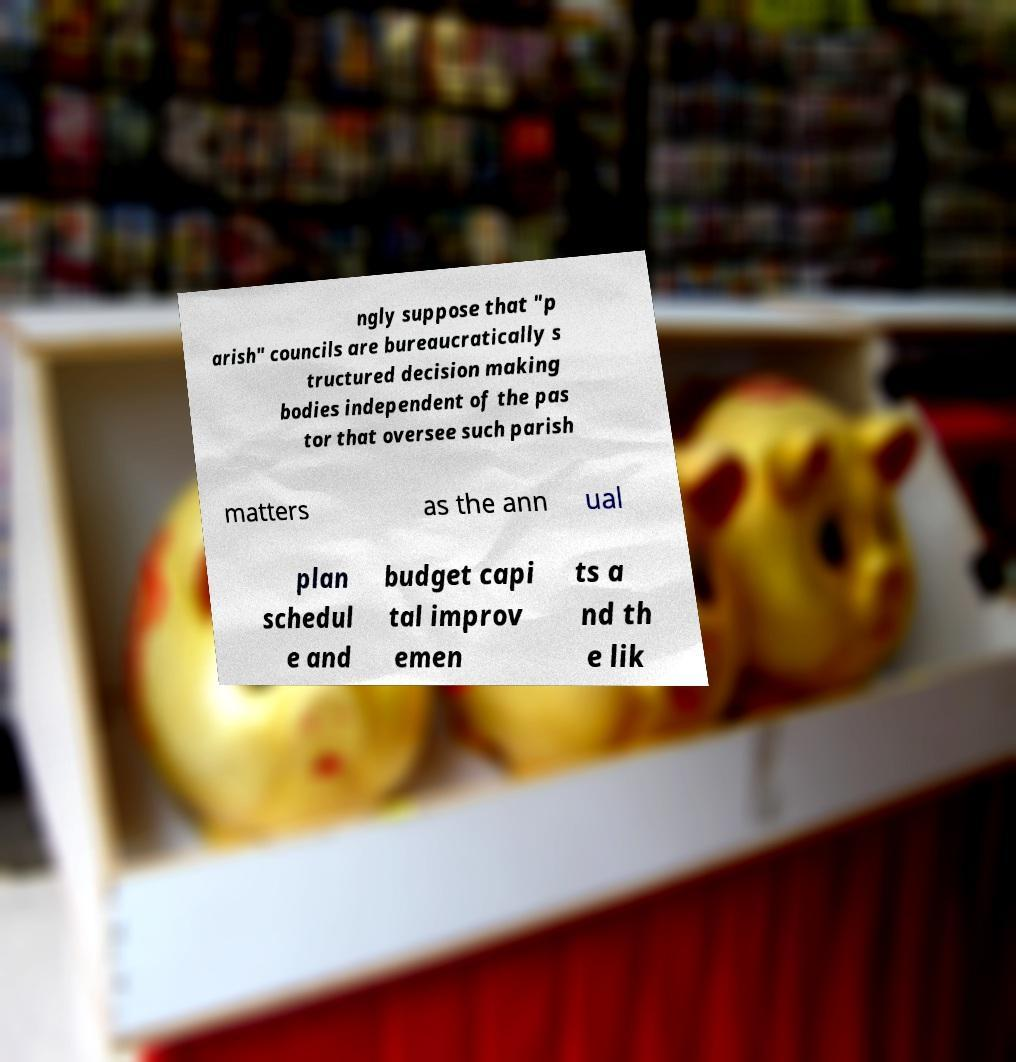Can you accurately transcribe the text from the provided image for me? ngly suppose that "p arish" councils are bureaucratically s tructured decision making bodies independent of the pas tor that oversee such parish matters as the ann ual plan schedul e and budget capi tal improv emen ts a nd th e lik 